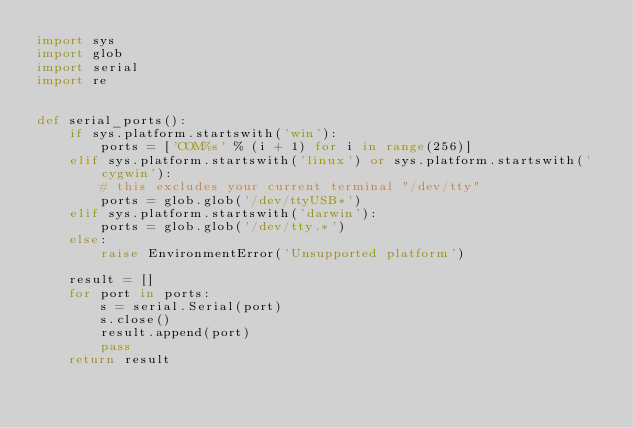<code> <loc_0><loc_0><loc_500><loc_500><_Python_>import sys
import glob
import serial
import re


def serial_ports():
    if sys.platform.startswith('win'):
        ports = ['COM%s' % (i + 1) for i in range(256)]
    elif sys.platform.startswith('linux') or sys.platform.startswith('cygwin'):
        # this excludes your current terminal "/dev/tty"
        ports = glob.glob('/dev/ttyUSB*')
    elif sys.platform.startswith('darwin'):
        ports = glob.glob('/dev/tty.*')
    else:
        raise EnvironmentError('Unsupported platform')

    result = []
    for port in ports:
        s = serial.Serial(port)
        s.close()
        result.append(port)
        pass
    return result
</code> 